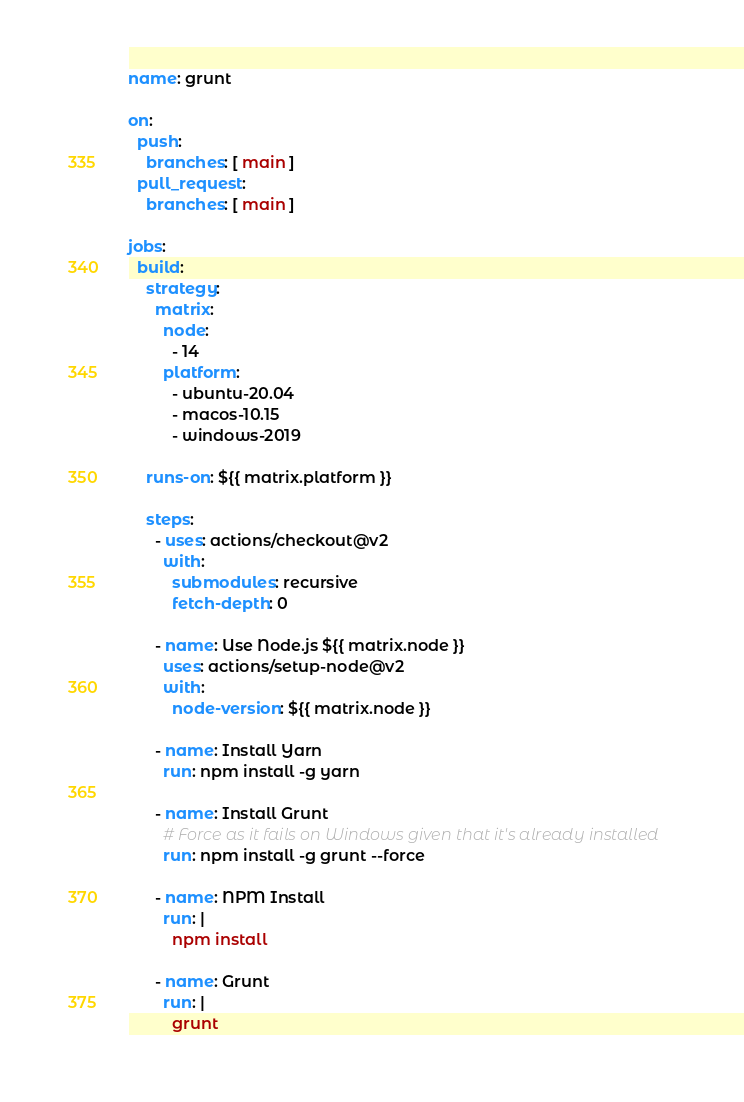<code> <loc_0><loc_0><loc_500><loc_500><_YAML_>name: grunt

on:
  push:
    branches: [ main ]
  pull_request:
    branches: [ main ]

jobs:
  build:
    strategy:
      matrix:
        node:
          - 14
        platform:
          - ubuntu-20.04
          - macos-10.15
          - windows-2019

    runs-on: ${{ matrix.platform }}

    steps:
      - uses: actions/checkout@v2
        with:
          submodules: recursive
          fetch-depth: 0

      - name: Use Node.js ${{ matrix.node }}
        uses: actions/setup-node@v2
        with:
          node-version: ${{ matrix.node }}

      - name: Install Yarn
        run: npm install -g yarn

      - name: Install Grunt
        # Force as it fails on Windows given that it's already installed
        run: npm install -g grunt --force

      - name: NPM Install
        run: |
          npm install

      - name: Grunt
        run: |
          grunt
</code> 